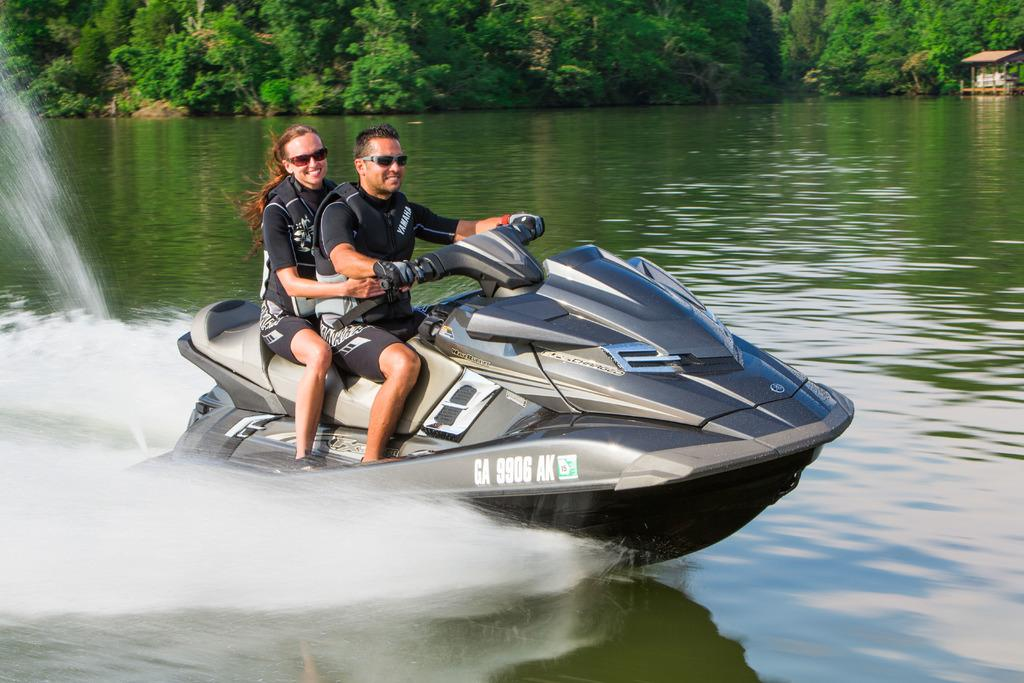How many people are in the foreground of the image? There are two persons in the foreground of the image. What are the two persons doing in the image? The two persons are boating in the water. What can be seen in the background of the image? There are trees and a shed in the background of the image. Where might this image have been taken? The image may have been taken at a lake, given the presence of water and the boating activity. What is the name of the throat condition that the person in the image is suffering from? There is no indication of any throat condition in the image, as it features two persons boating in the water. 